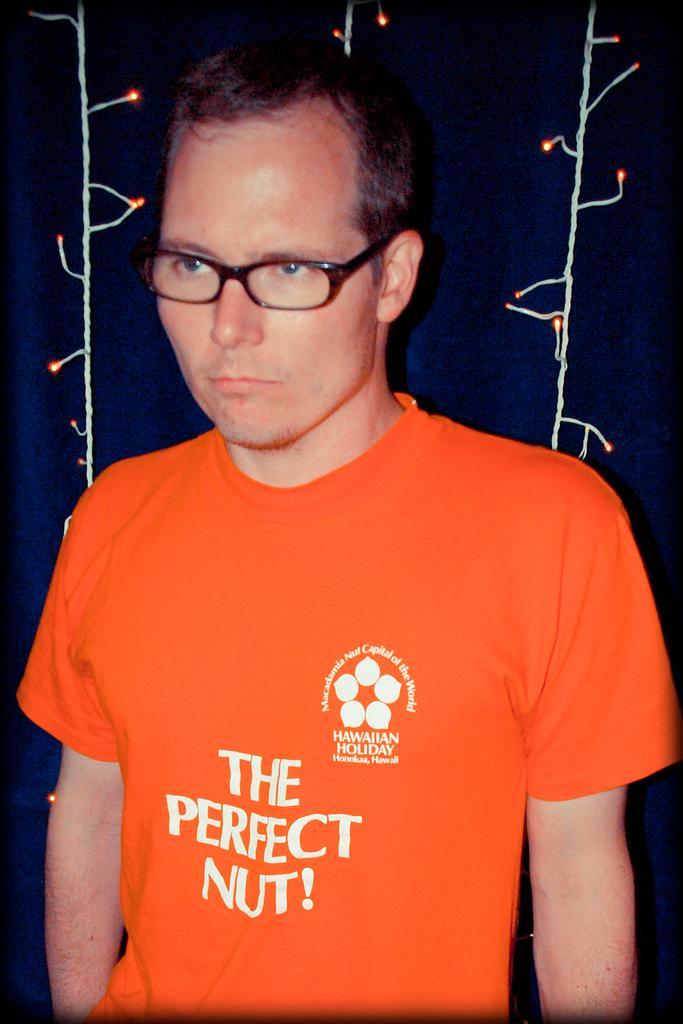Could you give a brief overview of what you see in this image? In this image we can see a person wearing glasses, behind the person there is decorative lights. 